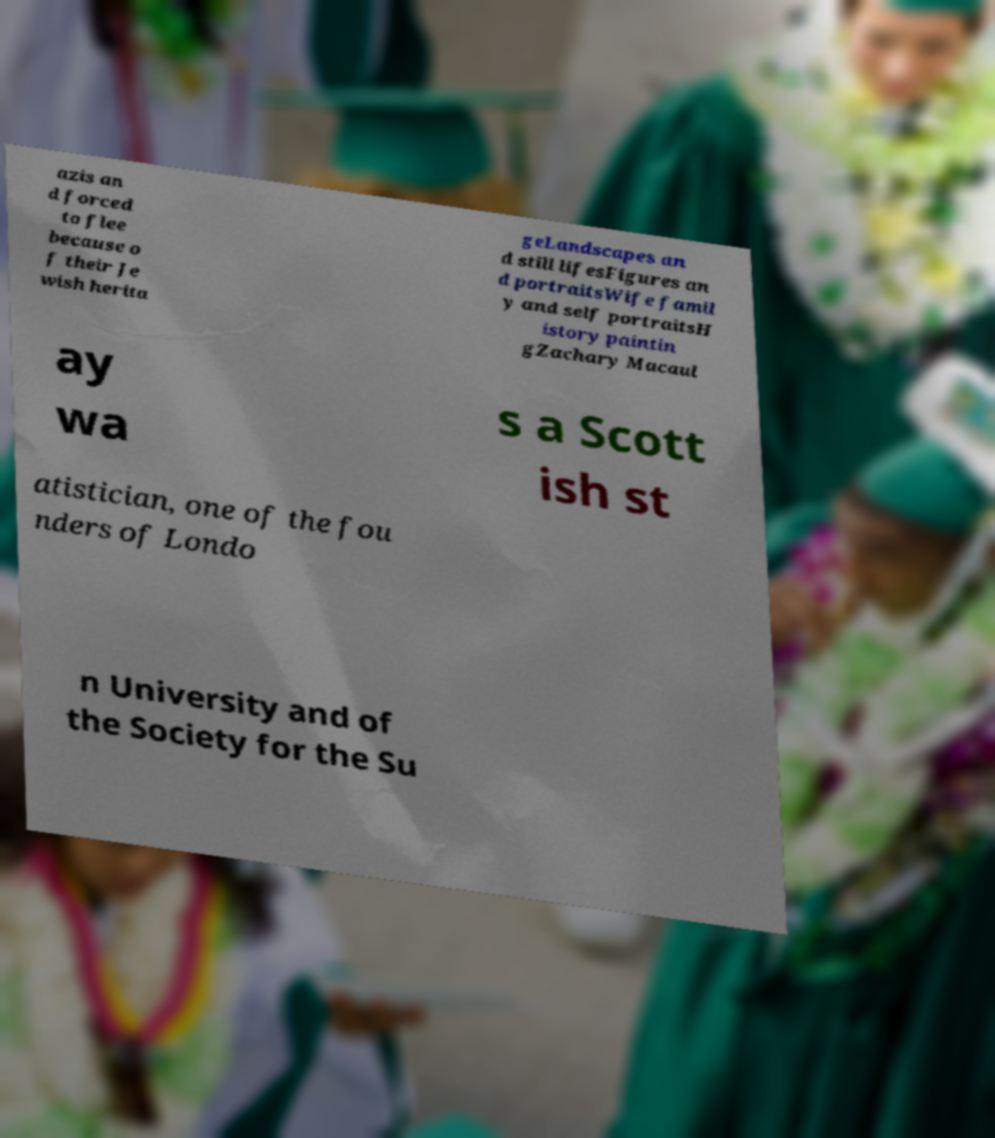I need the written content from this picture converted into text. Can you do that? azis an d forced to flee because o f their Je wish herita geLandscapes an d still lifesFigures an d portraitsWife famil y and self portraitsH istory paintin gZachary Macaul ay wa s a Scott ish st atistician, one of the fou nders of Londo n University and of the Society for the Su 